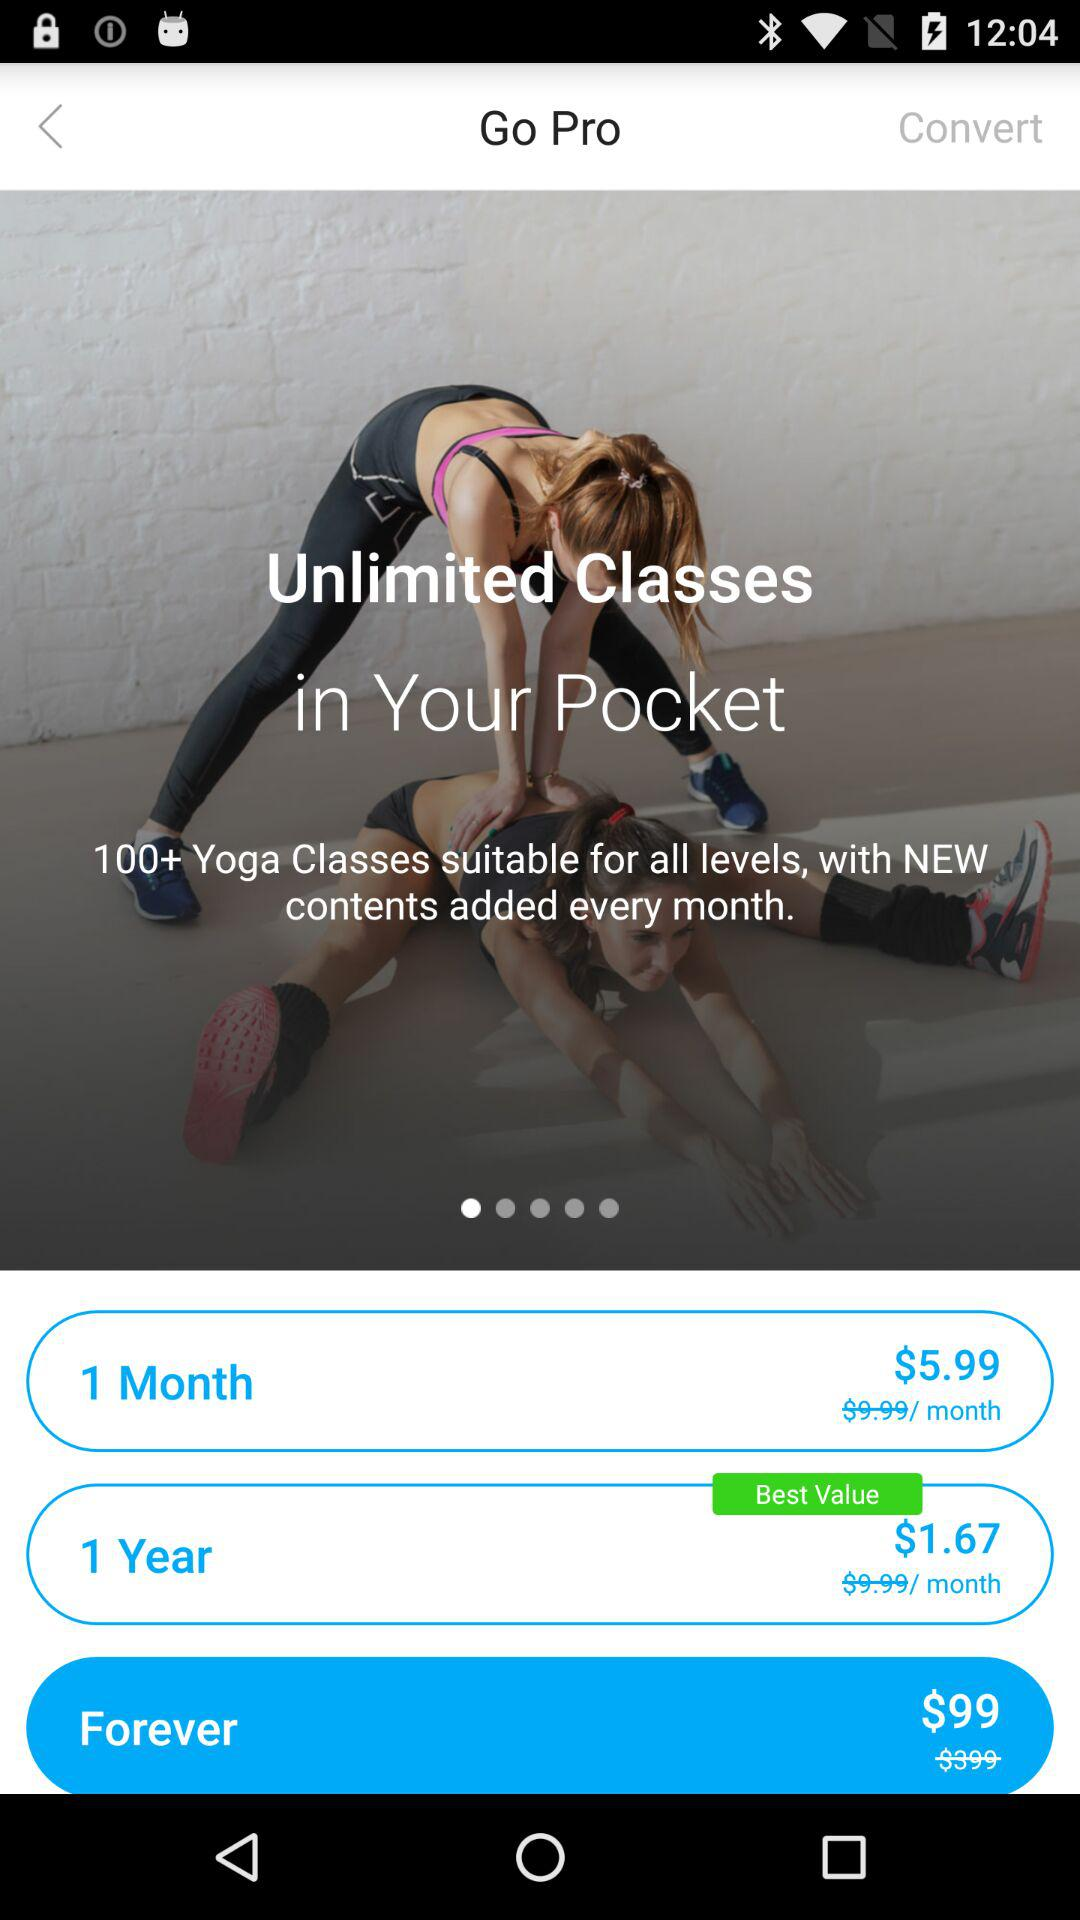What is the number of yoga classes? The number of yoga classes is 100+. 